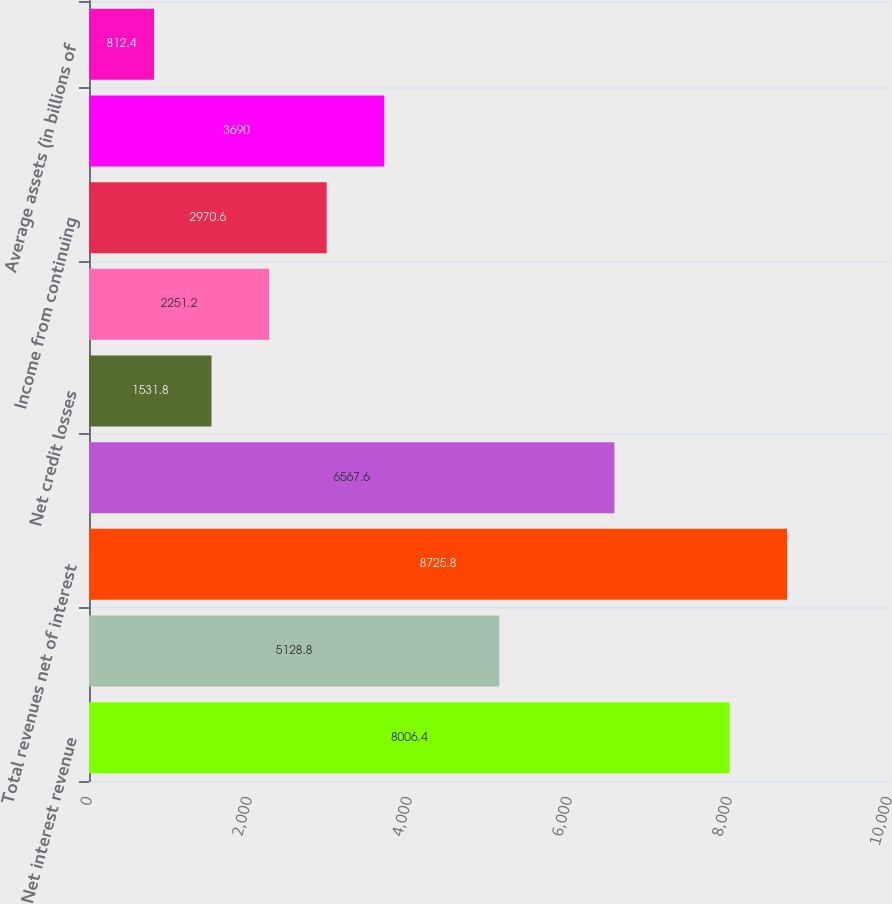<chart> <loc_0><loc_0><loc_500><loc_500><bar_chart><fcel>Net interest revenue<fcel>Non-interest revenue<fcel>Total revenues net of interest<fcel>Total operating expenses<fcel>Net credit losses<fcel>Provisions for loan losses and<fcel>Income from continuing<fcel>Net income<fcel>Average assets (in billions of<nl><fcel>8006.4<fcel>5128.8<fcel>8725.8<fcel>6567.6<fcel>1531.8<fcel>2251.2<fcel>2970.6<fcel>3690<fcel>812.4<nl></chart> 